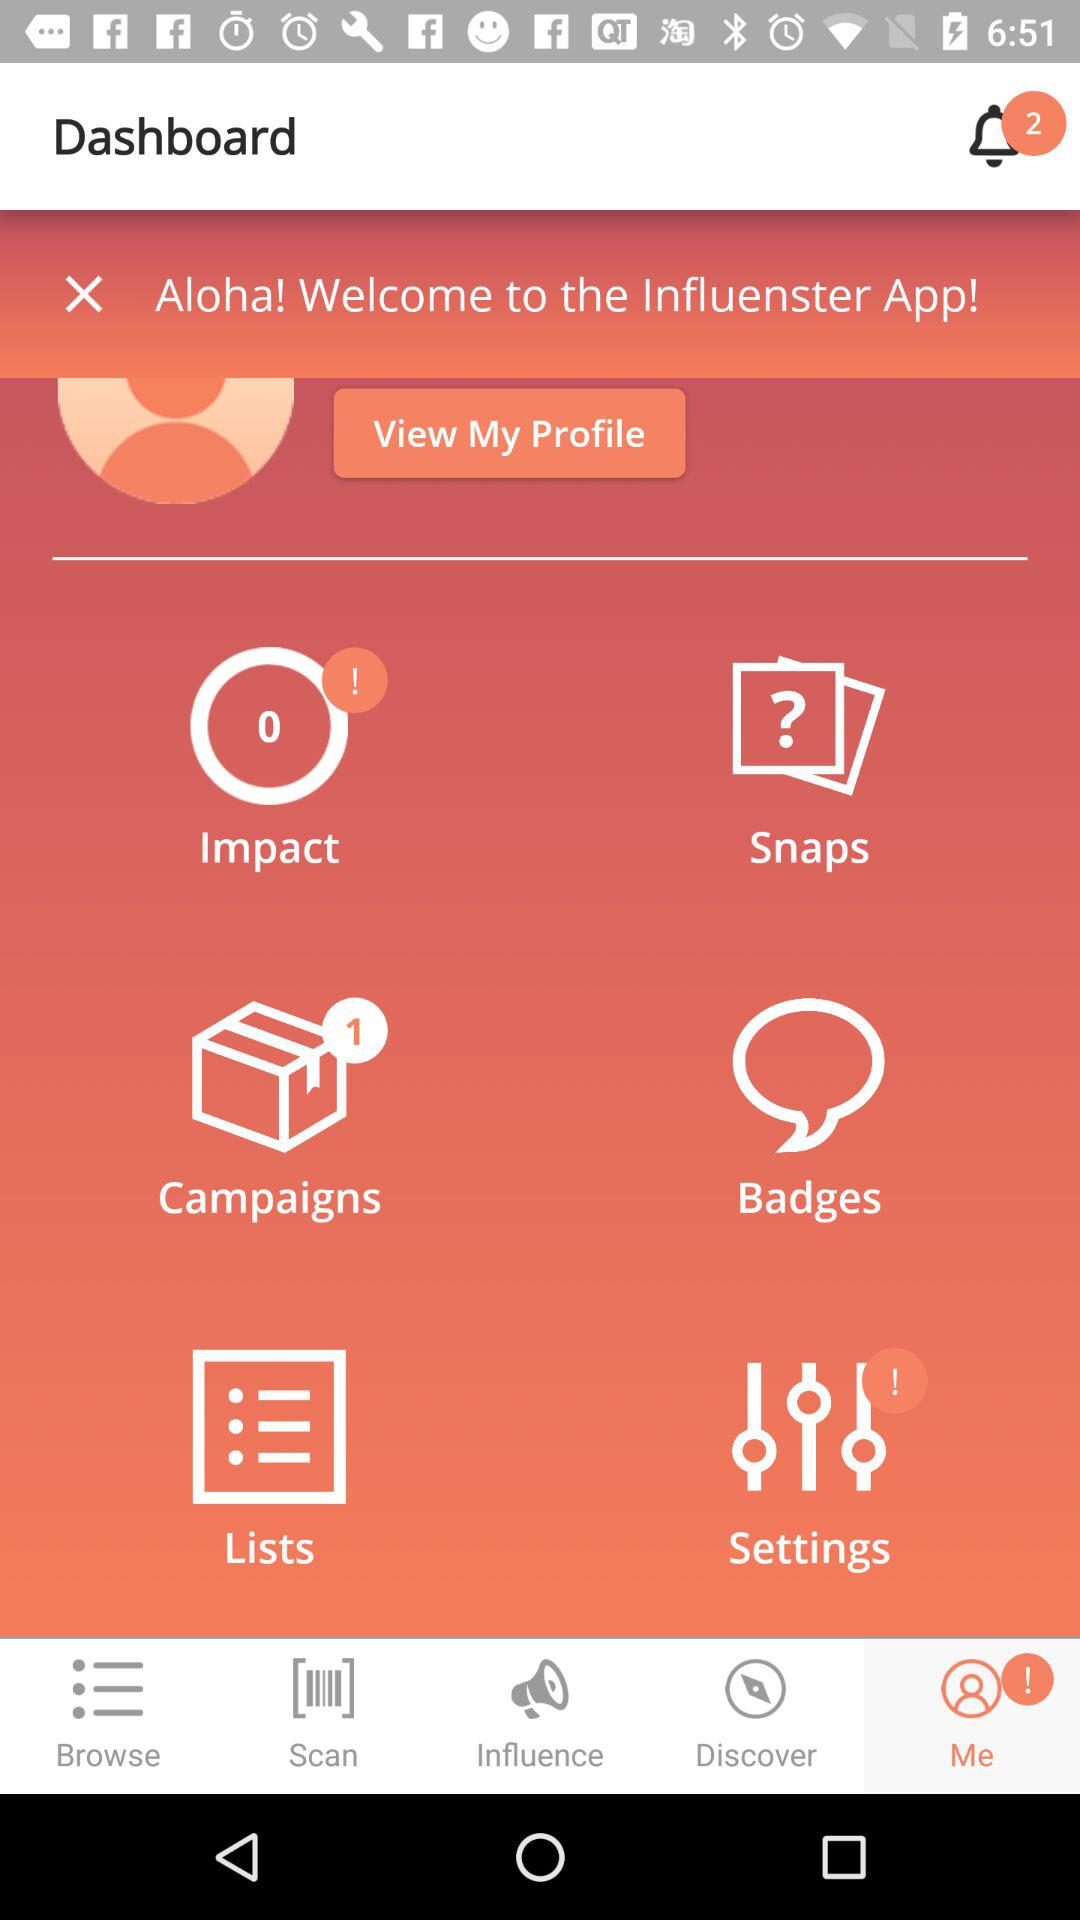What is the name of the application? The name of the application is "Influenster". 